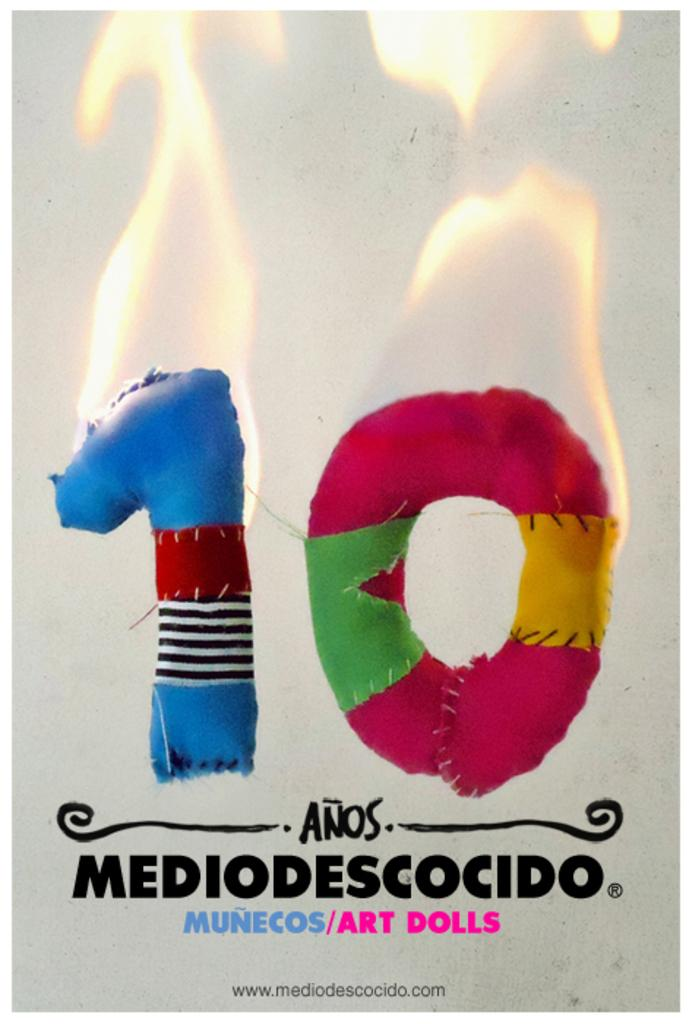What objects are present in the image that are made of cloth? There are pieces of cloth in the image. How are the pieces of cloth arranged? The pieces of cloth are arranged in the shape of a number. What is happening to the pieces of cloth? There is fire on the pieces of cloth. What can be found at the bottom of the image? There is text written at the bottom of the image. Where is the faucet located in the image? There is no faucet present in the image. What type of rifle is depicted in the image? There is no rifle present in the image. 